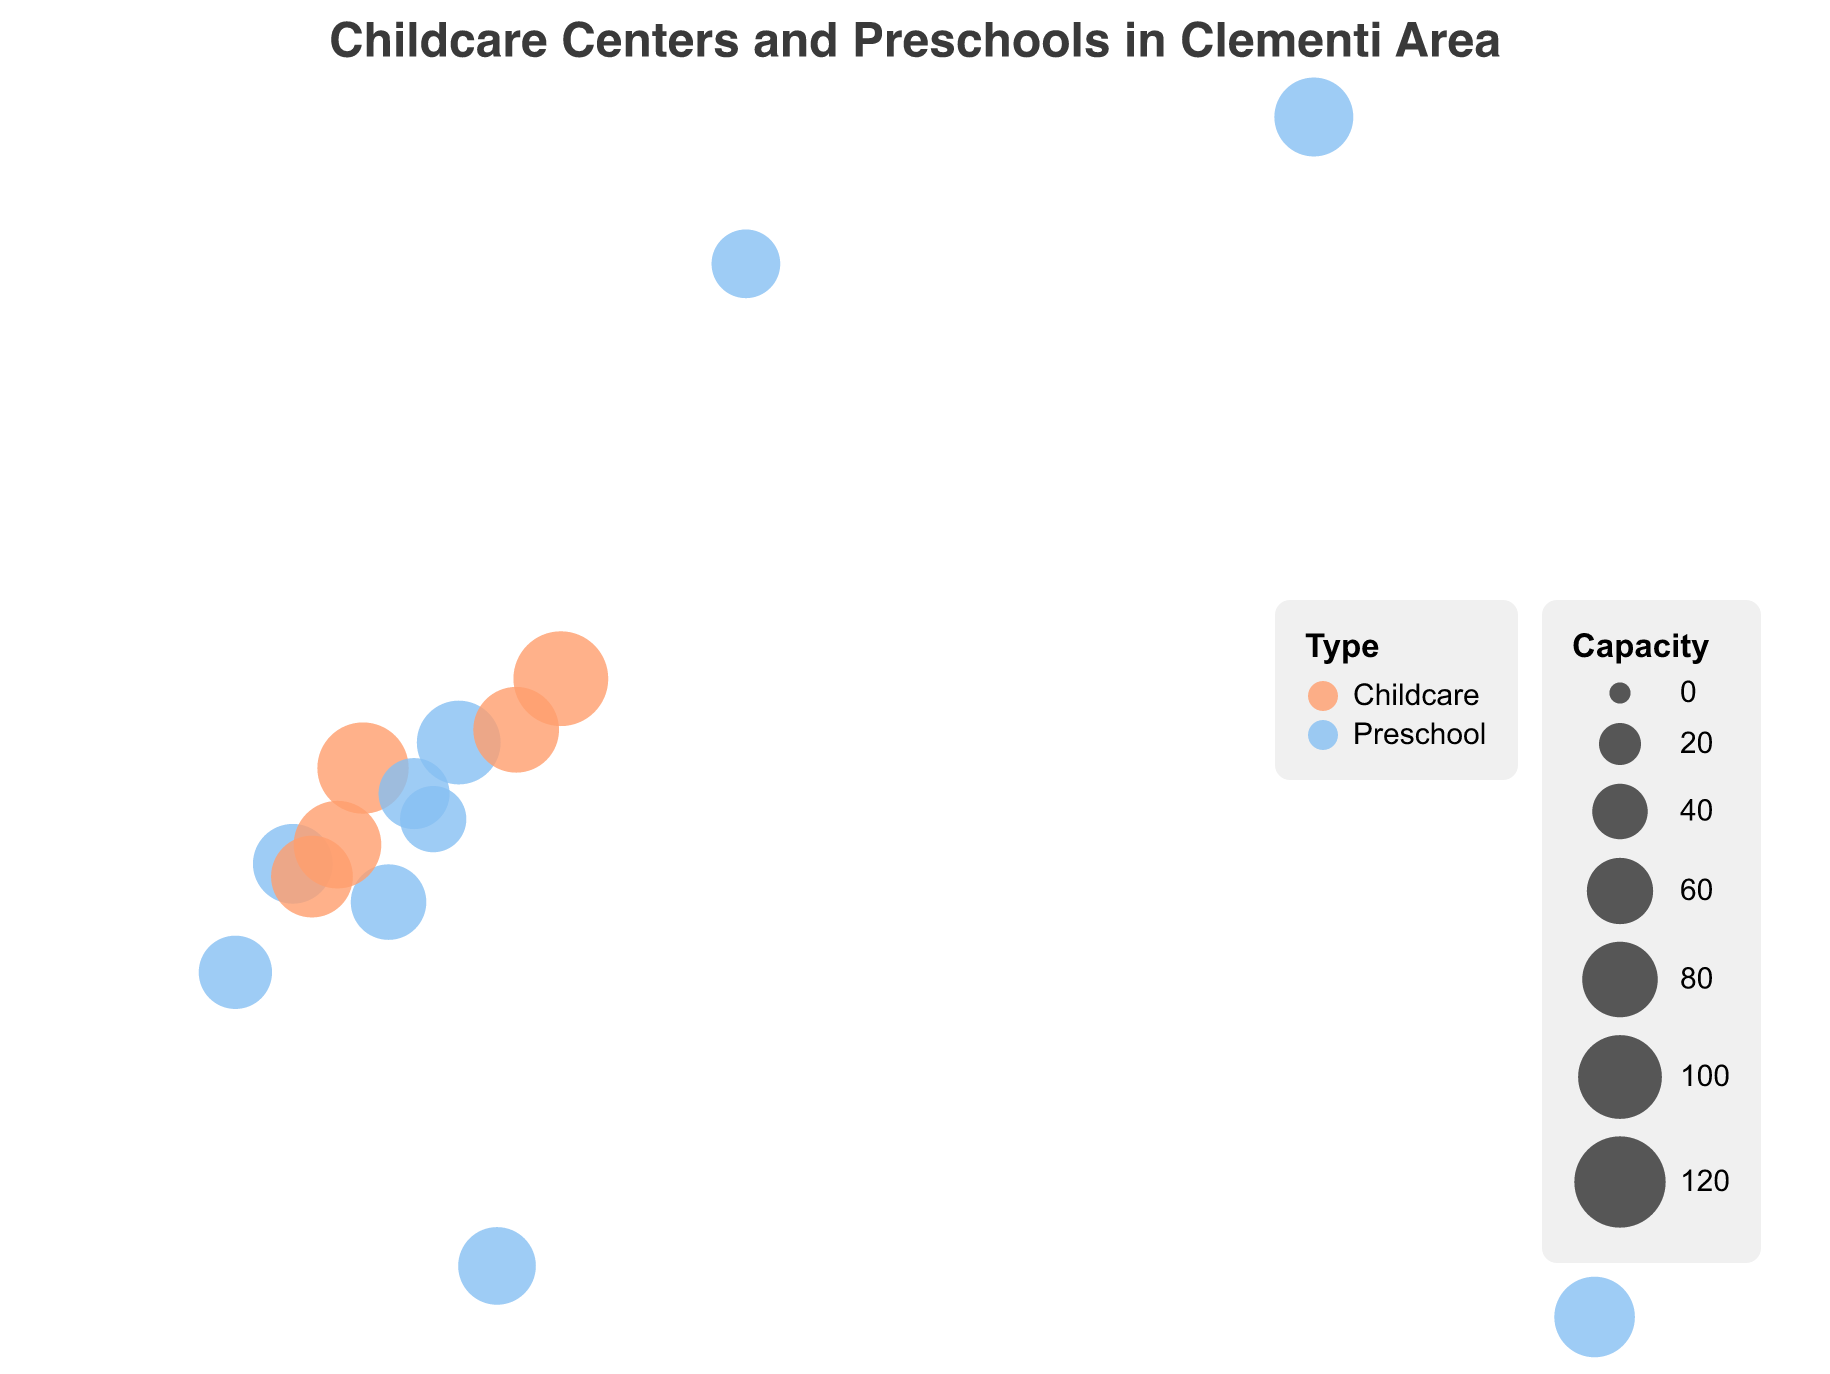How many childcare centers and preschools are there in Clementi? By counting the number of unique data points (marked as circles) within the visual figure, we can determine the total number of childcare centers and preschools in the Clementi area. There are 14 unique data points in the figure.
Answer: 14 Which childcare center has the largest capacity in Clementi? By examining the size of the circles (which represent the capacities of the centers), the largest circle among childcare centers represents NTUC First Campus (Clementi Ave 2) with a capacity of 130.
Answer: NTUC First Campus (Clementi Ave 2) Which institution is located furthest north among those plotted in the figure? To identify the institution located furthest north, we have to find the one with the highest latitude value on the map. By checking the plotted data, Pat's Schoolhouse (Bukit Timah) with a latitude of 1.3255 is furthest north.
Answer: Pat's Schoolhouse (Bukit Timah) What is the total capacity of all childcare centers in Clementi? Adding up the capacities of the childcare centers: 120 (My First Skool) + 110 (My World) + 95 (Busy Bees) + 130 (NTUC First Campus) + 105 (Kidz Meadow) yields a total capacity of 560.
Answer: 560 Which type of institution, preschool or childcare, has a greater average capacity in Clementi? To determine the average capacity, sum the capacities for each type and then divide by the number of centers for each type. For preschools: (90+100+80+60+70+85+75+65+88+92)/10 = 80.5. For childcare centers: (120+110+95+130+105)/5 = 112. The average capacity for childcare centers is greater.
Answer: Childcare Are there more preschools or childcare centers in Clementi? By counting the number of institutions of each type in the visual plot, we can find that there are 10 preschools and 5 childcare centers. There are more preschools than childcare centers.
Answer: More preschools Which preschool has the second-largest capacity in Clementi? To find the second-largest capacity among preschools, first identify the capacities: 90, 100, 80, 60, 70, 85, 75, 65, 88, and 92. The largest is 100, and the second-largest is 92 (ELFA Preschool at Dover).
Answer: ELFA Preschool @ Dover What is the closest preschool to My First Skool (Clementi Ave 4)? By checking the coordinates of nearby preschools and comparing their distance from My First Skool (1.3153, 103.7647), the closest preschool is PCF Sparkletots Preschool @ Clementi Blk 420 (1.3138, 103.7636).
Answer: PCF Sparkletots Preschool @ Clementi Blk 420 Which institution has a larger capacity, Busy Bees (Clementi) or E-Bridge Pre-School (Clementi)? By comparing their capacities, Busy Bees (Clementi) has a capacity of 95 and E-Bridge Pre-School (Clementi) has a capacity of 100. E-Bridge Pre-School (Clementi) has a larger capacity.
Answer: E-Bridge Pre-School (Clementi) What is the capacity difference between the largest and smallest childcare centers in Clementi? The largest childcare center is NTUC First Campus (Clementi Ave 2) with 130 capacity, and the smallest is Busy Bees (Clementi) with 95 capacity. The capacity difference is 130 - 95 = 35.
Answer: 35 